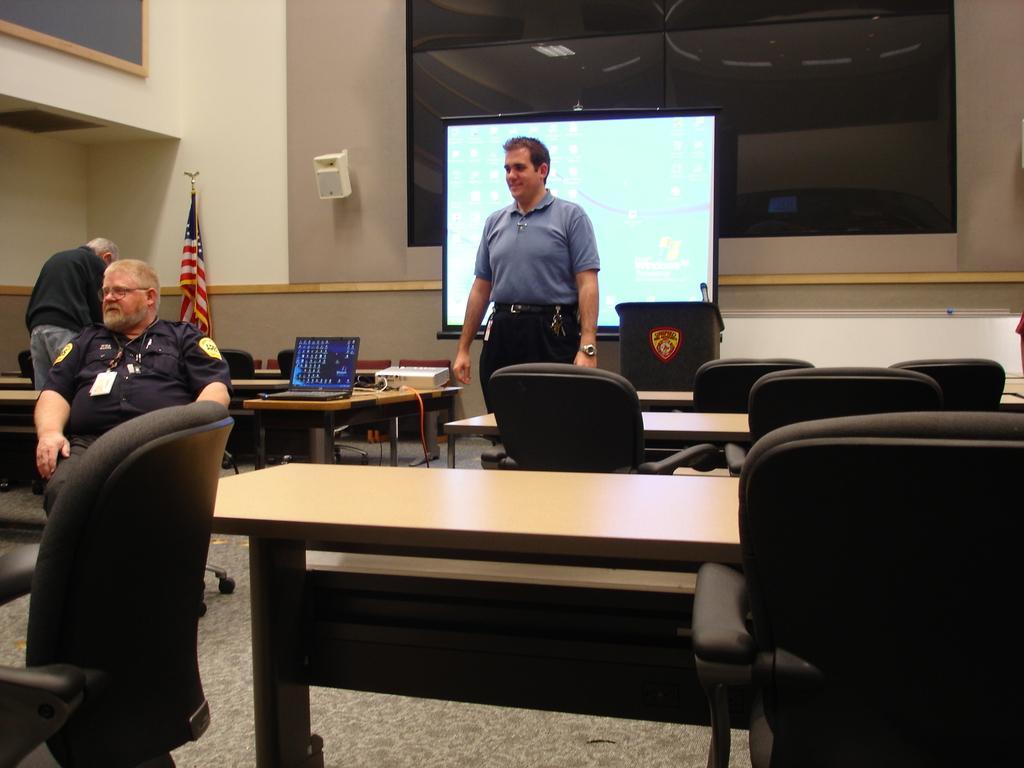In one or two sentences, can you explain what this image depicts? In this image I can see three men where a man is sitting on a chair and rest both are standing. In the background I can see a laptop, a flag and a screen. I can also see few more chairs and tables. 